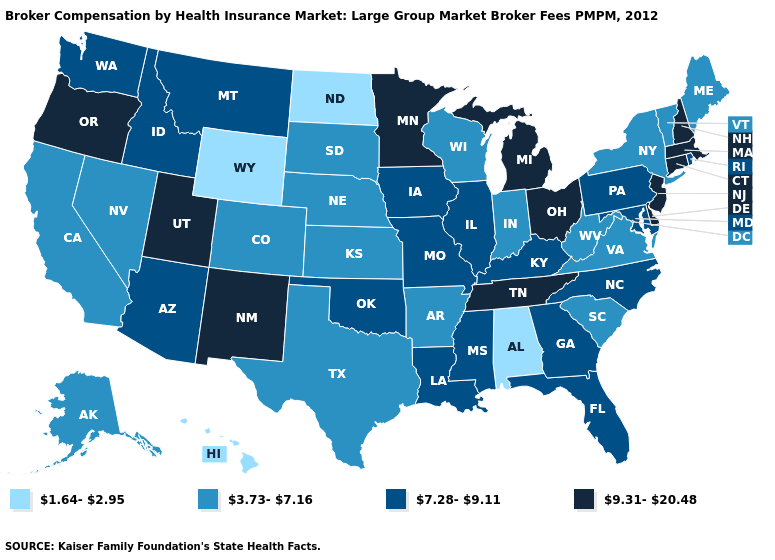Among the states that border Maryland , which have the highest value?
Answer briefly. Delaware. Does the first symbol in the legend represent the smallest category?
Answer briefly. Yes. What is the value of Idaho?
Write a very short answer. 7.28-9.11. What is the value of Wisconsin?
Write a very short answer. 3.73-7.16. Does Minnesota have the highest value in the MidWest?
Quick response, please. Yes. What is the highest value in the USA?
Short answer required. 9.31-20.48. How many symbols are there in the legend?
Write a very short answer. 4. Which states hav the highest value in the MidWest?
Short answer required. Michigan, Minnesota, Ohio. How many symbols are there in the legend?
Keep it brief. 4. Name the states that have a value in the range 7.28-9.11?
Concise answer only. Arizona, Florida, Georgia, Idaho, Illinois, Iowa, Kentucky, Louisiana, Maryland, Mississippi, Missouri, Montana, North Carolina, Oklahoma, Pennsylvania, Rhode Island, Washington. What is the value of Nebraska?
Keep it brief. 3.73-7.16. Name the states that have a value in the range 1.64-2.95?
Keep it brief. Alabama, Hawaii, North Dakota, Wyoming. Does the map have missing data?
Quick response, please. No. What is the highest value in the Northeast ?
Answer briefly. 9.31-20.48. What is the lowest value in the USA?
Quick response, please. 1.64-2.95. 